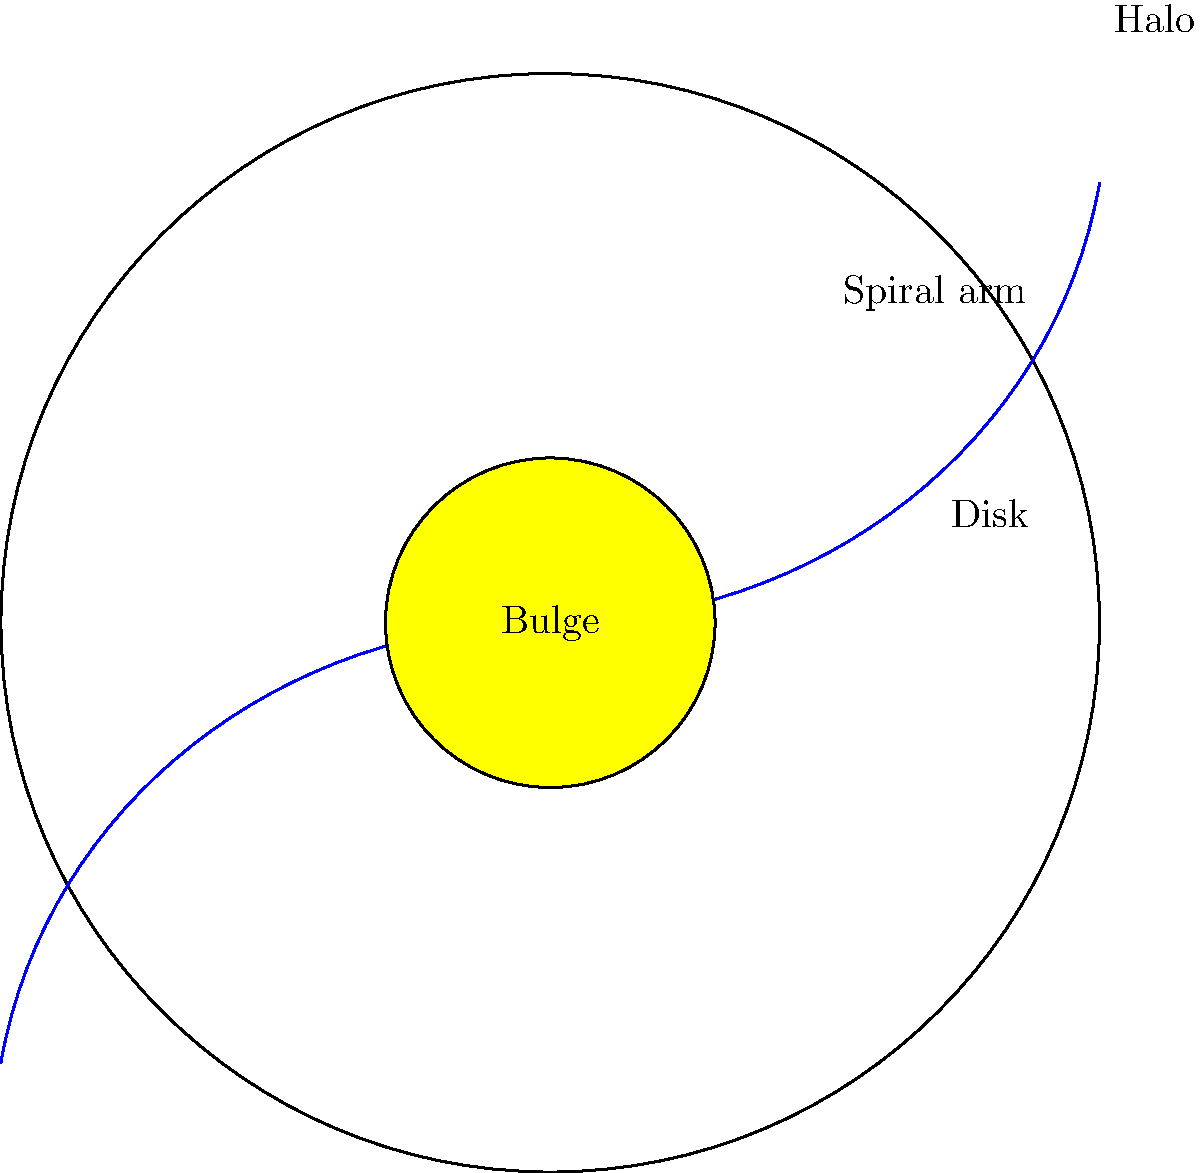As a night owl psychology undergraduate studying the influence of social and cultural factors on individual behavior, you've stumbled upon an interesting analogy between spiral galaxies and human societies. Identify the component of a spiral galaxy that is most analogous to the "core cultural values" of a society, and explain why this comparison might be relevant to your studies. To answer this question, let's break down the structure of a spiral galaxy and compare it to the structure of human societies:

1. Bulge: The central, densely packed region of a spiral galaxy.
   - In societies: This represents the core cultural values and beliefs.
   - Both are central, foundational, and influence the entire system.

2. Disk: The flat, circular region surrounding the bulge.
   - In societies: This could represent the broader cultural practices and norms.
   - Both extend from the center and contain most of the visible matter/activity.

3. Spiral arms: The distinctive spiral patterns extending from the disk.
   - In societies: These might represent various subcultures or cultural variations.
   - Both branch out from the main structure and add complexity.

4. Halo: The sparse, spherical region surrounding the entire galaxy.
   - In societies: This could represent external influences or global context.
   - Both encompass the entire system and interact with it.

The component most analogous to "core cultural values" is the bulge. This is because:

1. Central location: Like core values in a society, the bulge is at the center of the galaxy.
2. Density: The bulge is the densest part of the galaxy, similar to how core values are deeply ingrained in a culture.
3. Influence: The bulge's gravity affects the entire galaxy, just as core values influence all aspects of a society.
4. Age: The bulge often contains the oldest stars, much like how core values are often the most long-standing beliefs in a culture.

This analogy is relevant to studying the influence of social and cultural factors on individual behavior because:

1. It provides a visual model for understanding how different aspects of culture interact.
2. It highlights the central importance of core values in shaping broader cultural patterns.
3. It suggests how individual behaviors (like stars) might be influenced by their position within the cultural structure.
4. It offers a framework for considering how cultural changes might propagate from the center outwards, or how external influences might affect the system as a whole.
Answer: The bulge, representing the dense central region of a spiral galaxy, is most analogous to core cultural values in a society. 